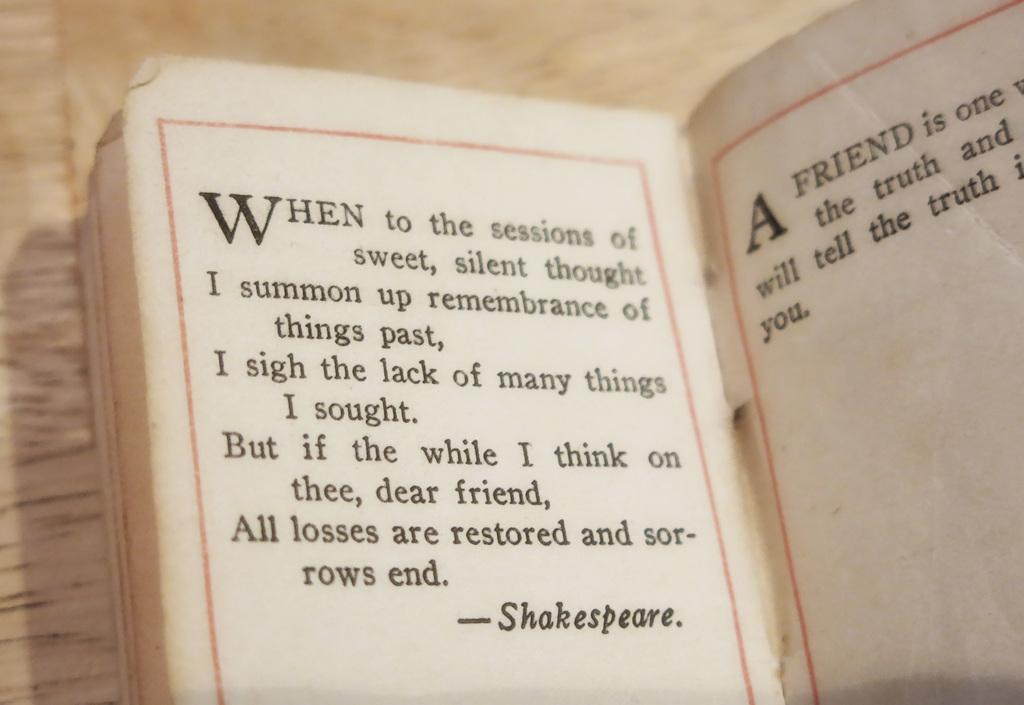<image>
Write a terse but informative summary of the picture. A book is open to a page with writing by Shakespeare. 